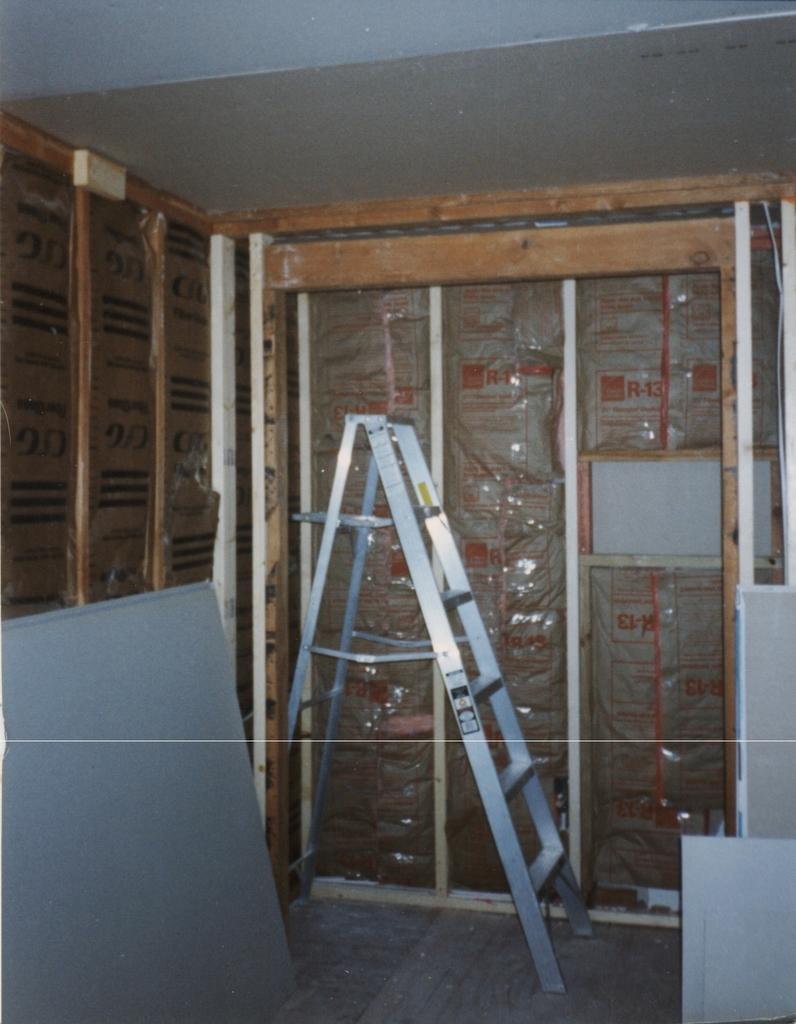Could you give a brief overview of what you see in this image? In the image in the center, we can see boards and one ladder. In the background there is a roof, glass and a few other objects. 